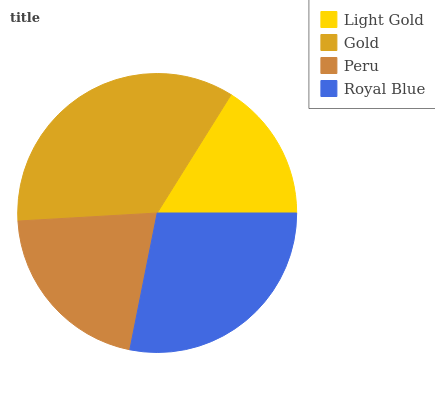Is Light Gold the minimum?
Answer yes or no. Yes. Is Gold the maximum?
Answer yes or no. Yes. Is Peru the minimum?
Answer yes or no. No. Is Peru the maximum?
Answer yes or no. No. Is Gold greater than Peru?
Answer yes or no. Yes. Is Peru less than Gold?
Answer yes or no. Yes. Is Peru greater than Gold?
Answer yes or no. No. Is Gold less than Peru?
Answer yes or no. No. Is Royal Blue the high median?
Answer yes or no. Yes. Is Peru the low median?
Answer yes or no. Yes. Is Peru the high median?
Answer yes or no. No. Is Gold the low median?
Answer yes or no. No. 